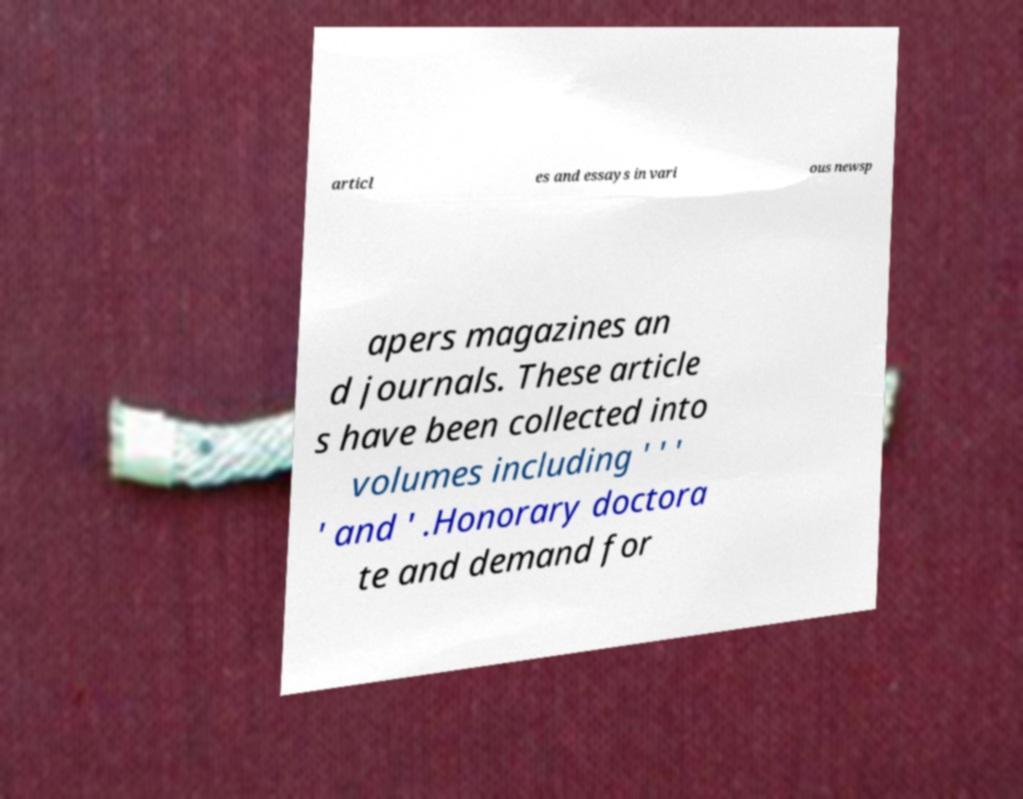What messages or text are displayed in this image? I need them in a readable, typed format. articl es and essays in vari ous newsp apers magazines an d journals. These article s have been collected into volumes including ' ' ' ' and ' .Honorary doctora te and demand for 